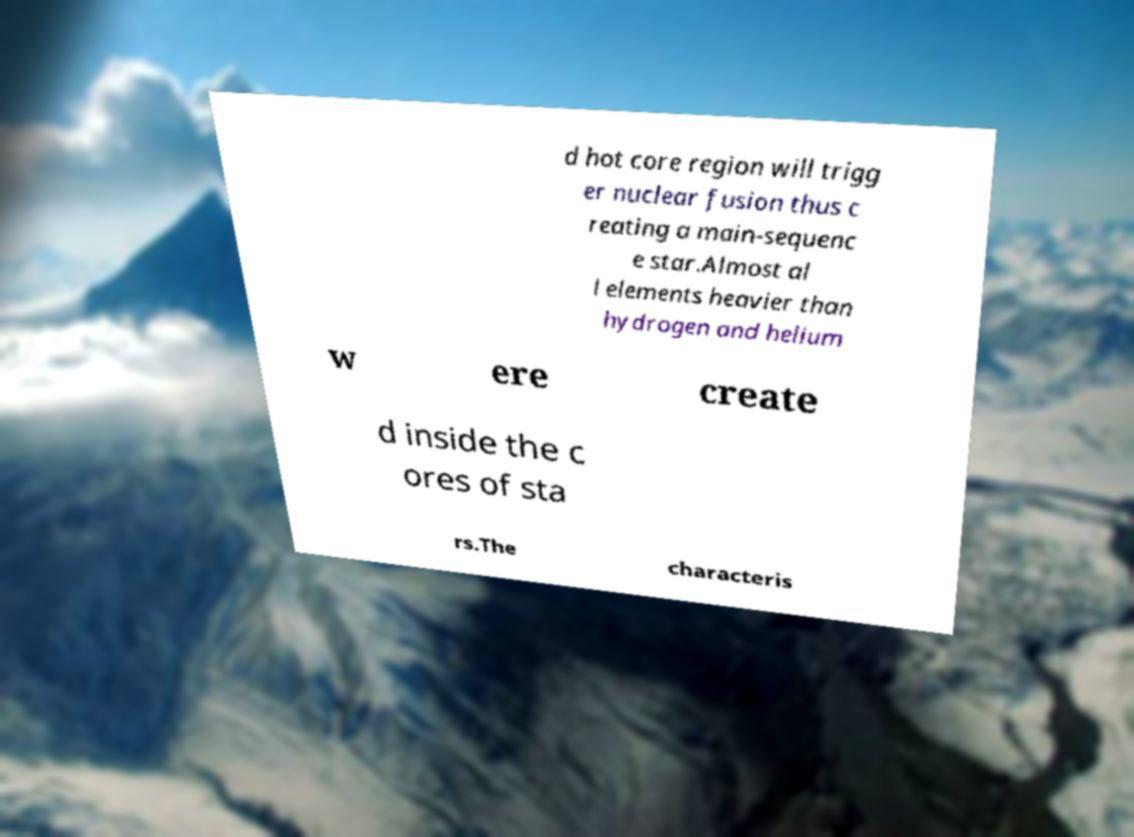Could you assist in decoding the text presented in this image and type it out clearly? d hot core region will trigg er nuclear fusion thus c reating a main-sequenc e star.Almost al l elements heavier than hydrogen and helium w ere create d inside the c ores of sta rs.The characteris 